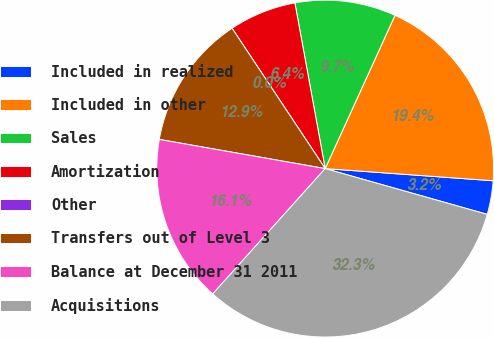<chart> <loc_0><loc_0><loc_500><loc_500><pie_chart><fcel>Included in realized<fcel>Included in other<fcel>Sales<fcel>Amortization<fcel>Other<fcel>Transfers out of Level 3<fcel>Balance at December 31 2011<fcel>Acquisitions<nl><fcel>3.23%<fcel>19.35%<fcel>9.68%<fcel>6.45%<fcel>0.0%<fcel>12.9%<fcel>16.13%<fcel>32.26%<nl></chart> 